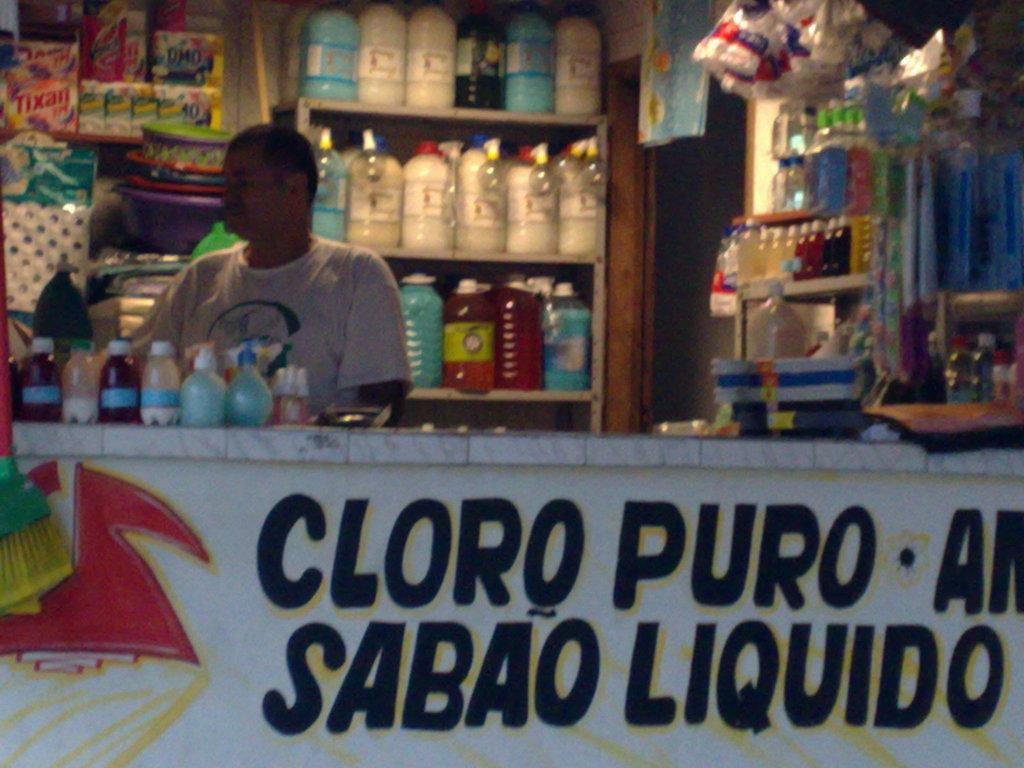What type of establishment is shown in the image? There is a shop in the image. Are there any people inside the shop? Yes, there are people standing in the shop. What type of products can be seen in the shop? Acid bottles and liquid bottles are present in the shop. How are the bottles arranged in the shop? The bottles are on racks in the shop. What advice is being given to the hill in the image? There is no hill present in the image, and therefore no advice is being given. 